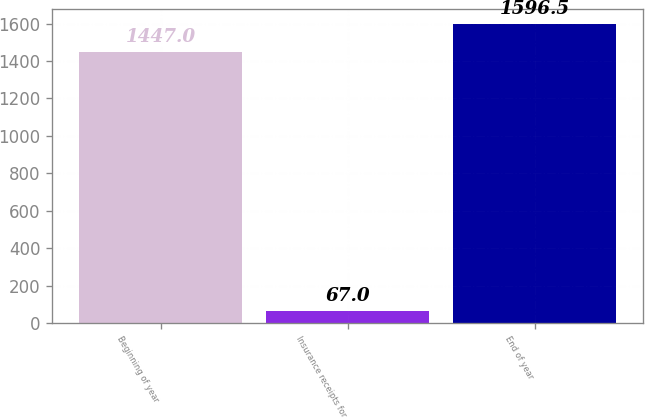Convert chart. <chart><loc_0><loc_0><loc_500><loc_500><bar_chart><fcel>Beginning of year<fcel>Insurance receipts for<fcel>End of year<nl><fcel>1447<fcel>67<fcel>1596.5<nl></chart> 